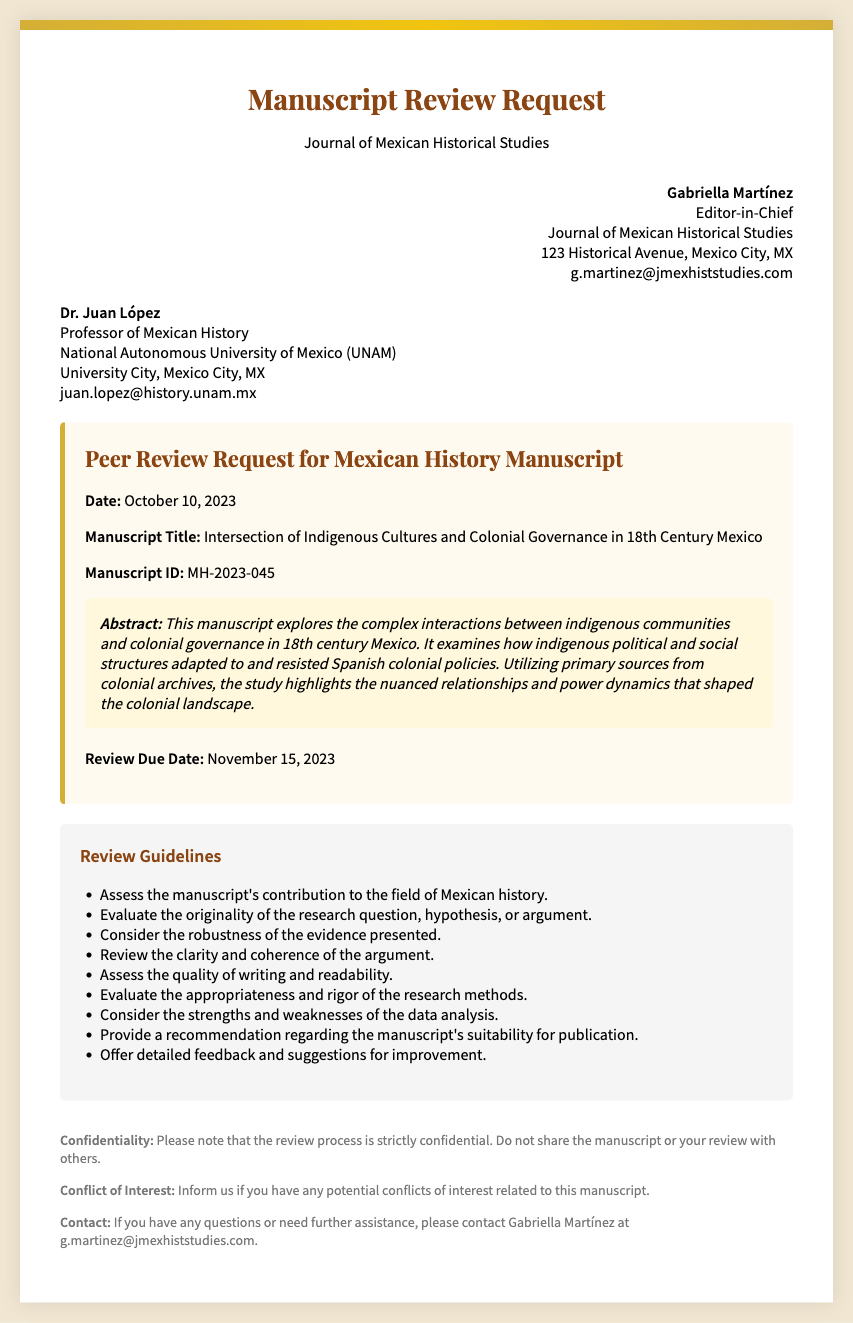What is the manuscript title? The manuscript title is explicitly mentioned in the document.
Answer: Intersection of Indigenous Cultures and Colonial Governance in 18th Century Mexico Who is the sender of the review request? The sender's name is clearly stated in the sender's section of the document.
Answer: Gabriella Martínez What is the manuscript ID? The manuscript ID is provided for identification purposes in the content section.
Answer: MH-2023-045 What is the review due date? The review due date appears in the content section of the document.
Answer: November 15, 2023 What is the main focus of the manuscript? The focus of the manuscript is outlined in the abstract, highlighting its key theme.
Answer: Complex interactions between indigenous communities and colonial governance How many review guidelines are listed? The number of guidelines can be counted from the guidelines section of the document.
Answer: Nine What does the confidentiality note request? The confidentiality note emphasizes an important aspect related to the review process.
Answer: Strictly confidential Who should be contacted for questions? The contact information is provided at the end of the document for inquiries.
Answer: Gabriella Martínez What aspect is assessed regarding the evidence presented? One of the review guidelines directly addresses the evaluation of this aspect.
Answer: Robustness of the evidence presented 